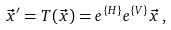Convert formula to latex. <formula><loc_0><loc_0><loc_500><loc_500>\vec { x } ^ { \prime } = T ( \vec { x } ) = e ^ { \{ H \} } e ^ { \{ V \} } \vec { x } \, ,</formula> 